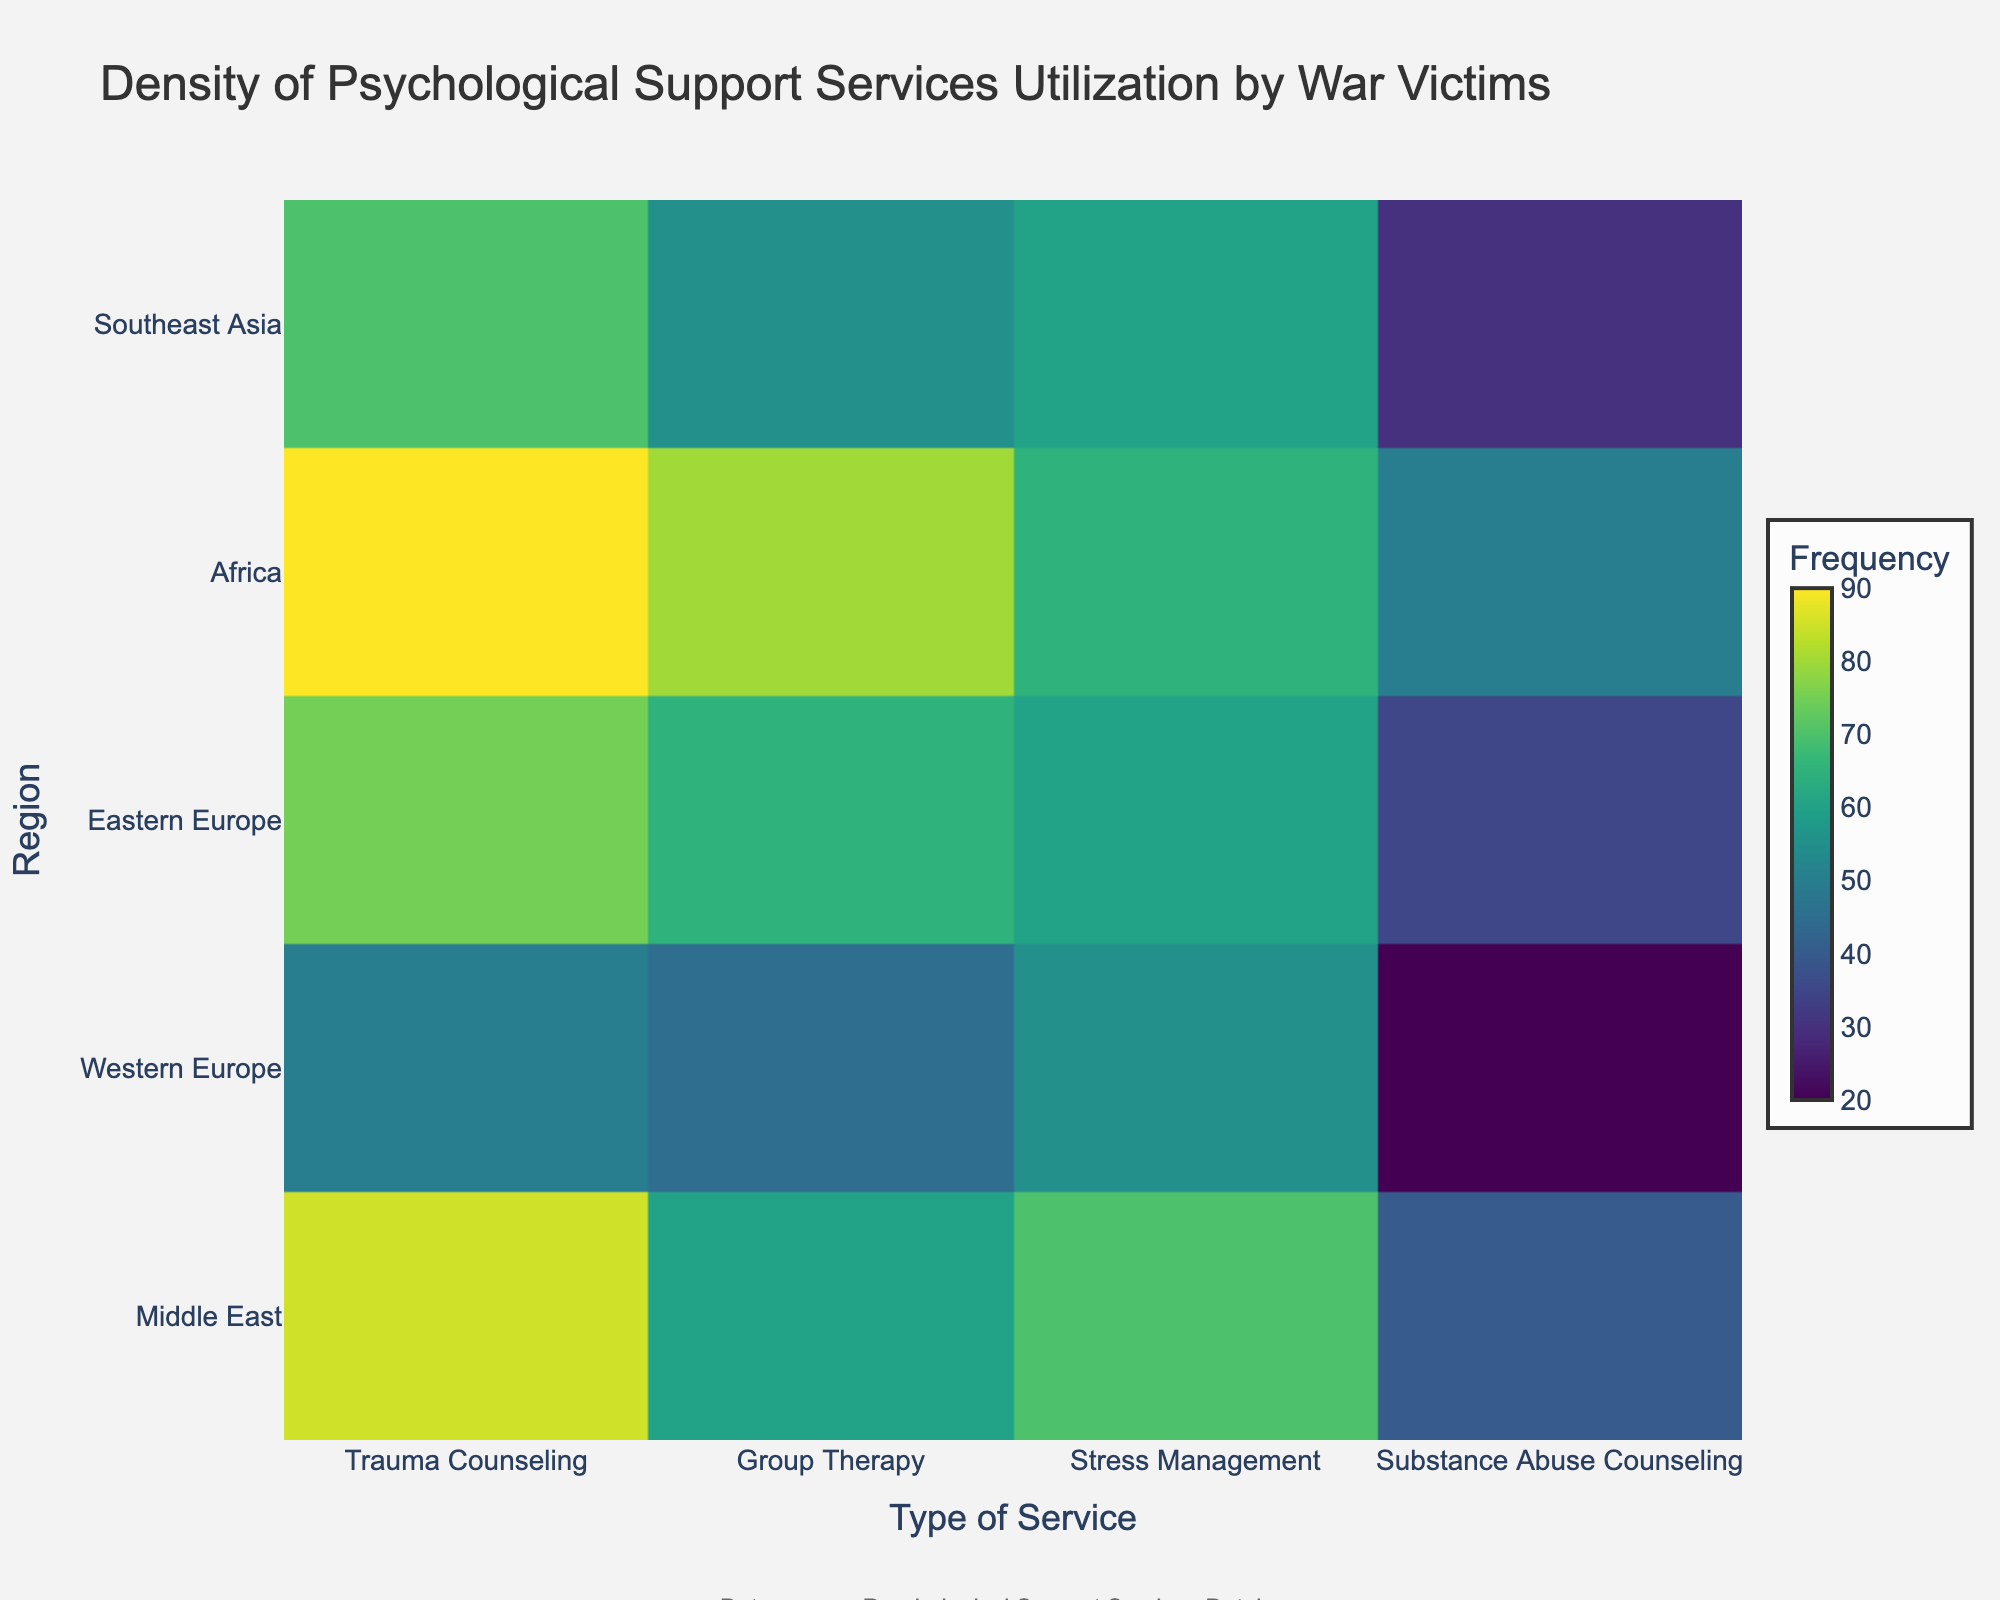What is the total number of types of services represented in this density plot? The x-axis shows the types of services. By counting the different services shown on the x-axis, we see there are four distinct types.
Answer: Four Which region has the highest frequency of Group Therapy usage? By looking at the density plot and identifying the highest value for Group Therapy along each row for regions, the value is highest at the row corresponding to Africa.
Answer: Africa How does the frequency of Trauma Counseling in Western Europe compare to the Middle East? By comparing the color intensity of the Trauma Counseling values between Western Europe and the Middle East, you can see that Middle East has a darker color indicating a higher frequency. Specifically, Middle East has 85 and Western Europe has 50.
Answer: Middle East is higher Which type of service has the lowest frequency usage in Southeast Asia? By looking at the color gradient for Southeast Asia across all types of services, Substance Abuse Counseling has the lightest color, indicating the lowest frequency. It specifically shows a value of 30.
Answer: Substance Abuse Counseling Calculate the average frequency of Stress Management services across all regions. Sum all the values for Stress Management: 70 (Middle East) + 55 (Western Europe) + 60 (Eastern Europe) + 65 (Africa) + 60 (Southeast Asia) = 310. Then, divide by the number of regions (5): 310 / 5 = 62.
Answer: 62 In which region is the utilization of Substance Abuse Counseling closest to the utilization of Group Therapy? Compare the differences in frequencies between Substance Abuse Counseling and Group Therapy for each region. Middle East: 60-40=20, Western Europe: 45-20=25, Eastern Europe: 65-35=30, Africa: 80-50=30, Southeast Asia: 55-30=25. The smallest difference is in the Middle East with 20.
Answer: Middle East Which region shows the most balanced usage across all four types of psychological support services? A region with balanced usage will have less variation in the frequencies of each type of service. By visually examining the figure, Africa has values 90, 80, 65, and 50, which are relatively close together compared to other regions.
Answer: Africa 